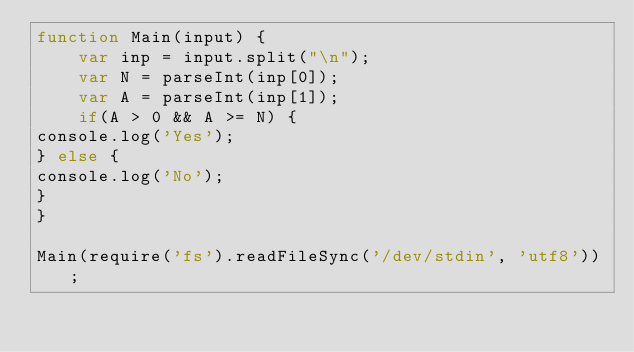Convert code to text. <code><loc_0><loc_0><loc_500><loc_500><_JavaScript_>function Main(input) {
    var inp = input.split("\n");
    var N = parseInt(inp[0]);
    var A = parseInt(inp[1]);
    if(A > 0 && A >= N) {
console.log('Yes');
} else {
console.log('No');
}
}
 
Main(require('fs').readFileSync('/dev/stdin', 'utf8'));</code> 